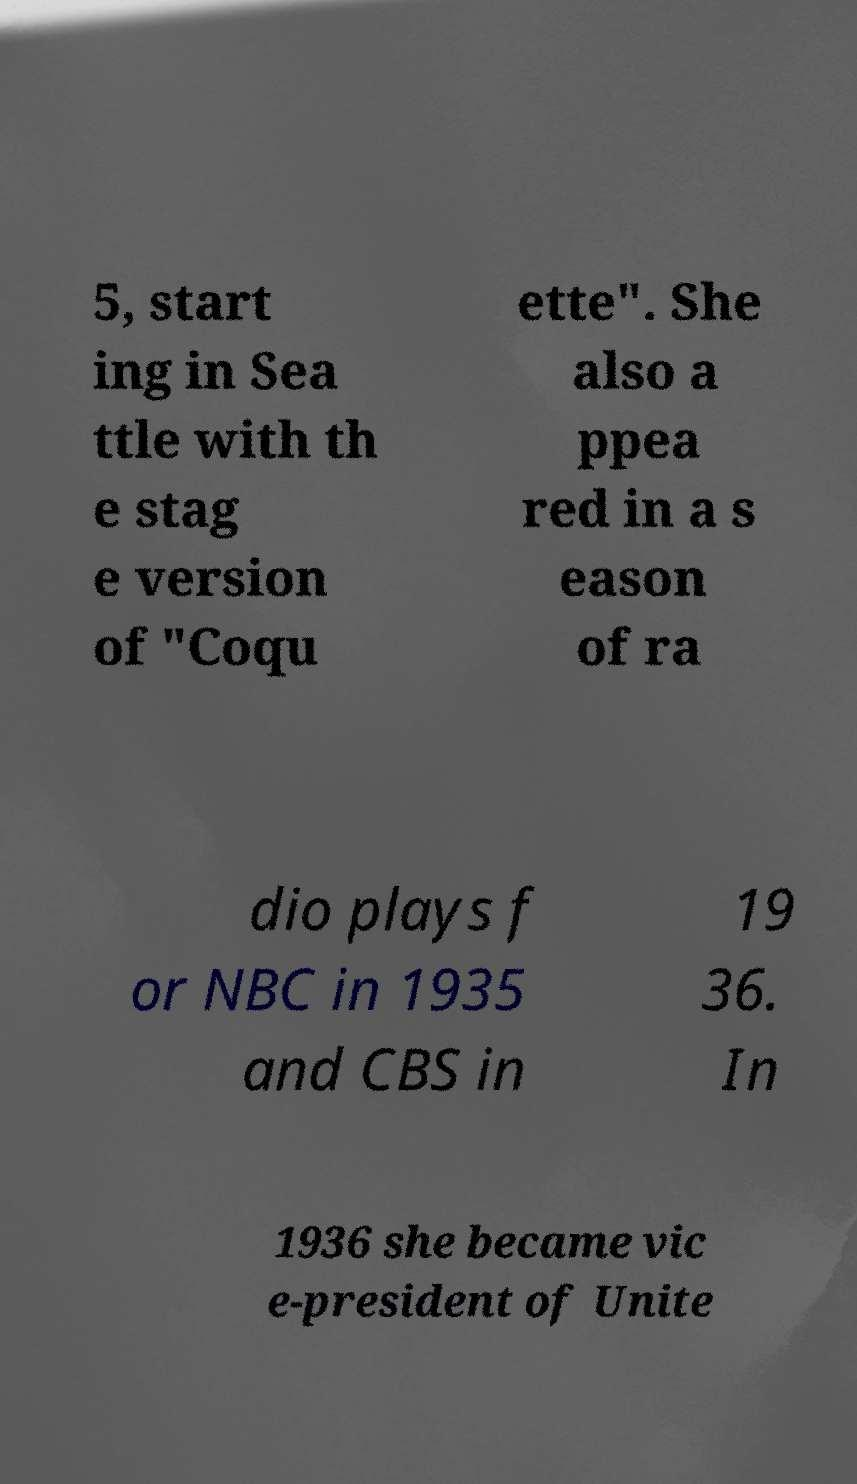Could you assist in decoding the text presented in this image and type it out clearly? 5, start ing in Sea ttle with th e stag e version of "Coqu ette". She also a ppea red in a s eason of ra dio plays f or NBC in 1935 and CBS in 19 36. In 1936 she became vic e-president of Unite 